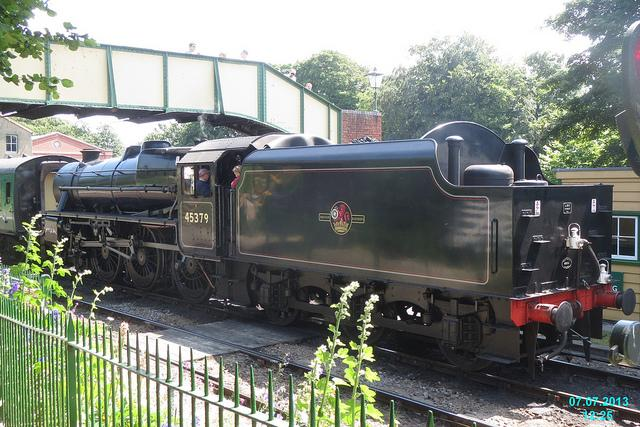What sort of traffic is allowed on the bridge over this train?

Choices:
A) foot
B) boat
C) none
D) large trucks foot 